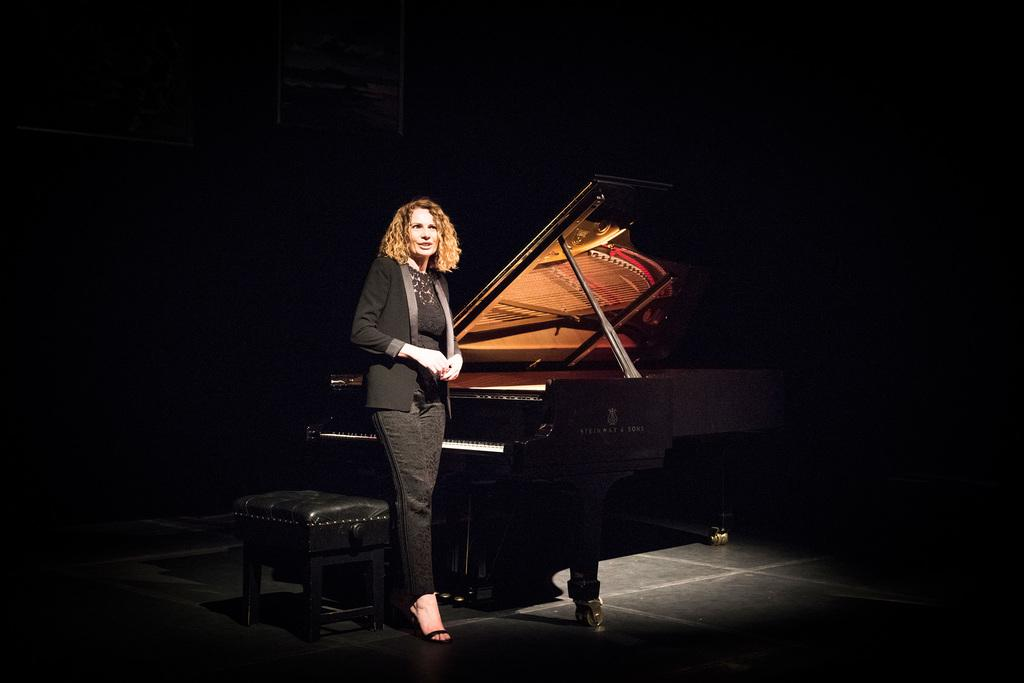What is present in the image? There is a woman and a piano in the image. Can you describe the position of the woman in the image? The woman is standing at the right side. What musical instrument can be seen in the image? There is a piano in the image. What type of cart is being used to transport the piano in the image? There is no cart present in the image, and the piano is not being transported. Can you tell me how many quills are visible on the piano in the image? There are no quills present in the image, as quills are not associated with pianos. 